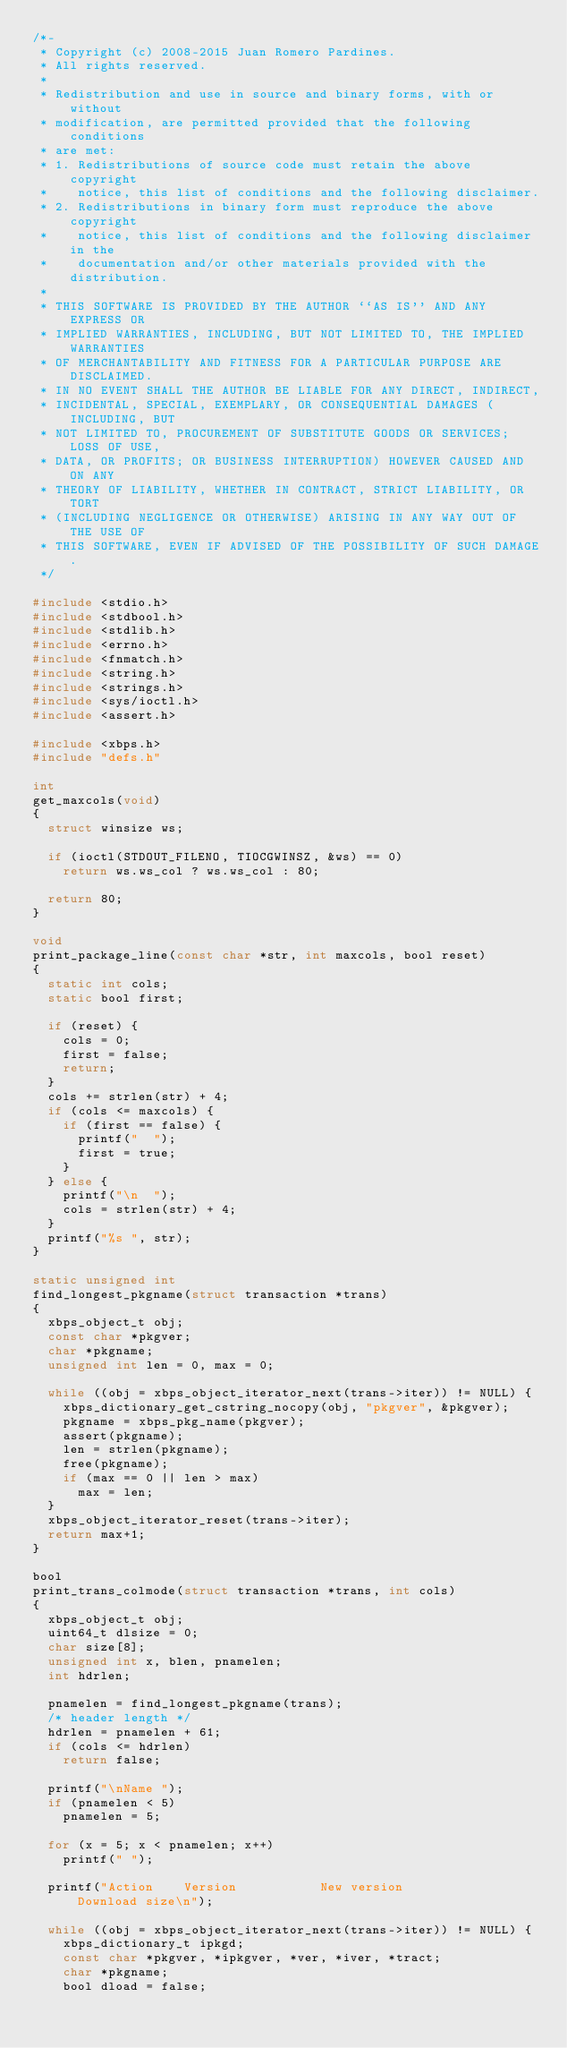Convert code to text. <code><loc_0><loc_0><loc_500><loc_500><_C_>/*-
 * Copyright (c) 2008-2015 Juan Romero Pardines.
 * All rights reserved.
 *
 * Redistribution and use in source and binary forms, with or without
 * modification, are permitted provided that the following conditions
 * are met:
 * 1. Redistributions of source code must retain the above copyright
 *    notice, this list of conditions and the following disclaimer.
 * 2. Redistributions in binary form must reproduce the above copyright
 *    notice, this list of conditions and the following disclaimer in the
 *    documentation and/or other materials provided with the distribution.
 *
 * THIS SOFTWARE IS PROVIDED BY THE AUTHOR ``AS IS'' AND ANY EXPRESS OR
 * IMPLIED WARRANTIES, INCLUDING, BUT NOT LIMITED TO, THE IMPLIED WARRANTIES
 * OF MERCHANTABILITY AND FITNESS FOR A PARTICULAR PURPOSE ARE DISCLAIMED.
 * IN NO EVENT SHALL THE AUTHOR BE LIABLE FOR ANY DIRECT, INDIRECT,
 * INCIDENTAL, SPECIAL, EXEMPLARY, OR CONSEQUENTIAL DAMAGES (INCLUDING, BUT
 * NOT LIMITED TO, PROCUREMENT OF SUBSTITUTE GOODS OR SERVICES; LOSS OF USE,
 * DATA, OR PROFITS; OR BUSINESS INTERRUPTION) HOWEVER CAUSED AND ON ANY
 * THEORY OF LIABILITY, WHETHER IN CONTRACT, STRICT LIABILITY, OR TORT
 * (INCLUDING NEGLIGENCE OR OTHERWISE) ARISING IN ANY WAY OUT OF THE USE OF
 * THIS SOFTWARE, EVEN IF ADVISED OF THE POSSIBILITY OF SUCH DAMAGE.
 */

#include <stdio.h>
#include <stdbool.h>
#include <stdlib.h>
#include <errno.h>
#include <fnmatch.h>
#include <string.h>
#include <strings.h>
#include <sys/ioctl.h>
#include <assert.h>

#include <xbps.h>
#include "defs.h"

int
get_maxcols(void)
{
	struct winsize ws;

	if (ioctl(STDOUT_FILENO, TIOCGWINSZ, &ws) == 0)
		return ws.ws_col ? ws.ws_col : 80;

	return 80;
}

void
print_package_line(const char *str, int maxcols, bool reset)
{
	static int cols;
	static bool first;

	if (reset) {
		cols = 0;
		first = false;
		return;
	}
	cols += strlen(str) + 4;
	if (cols <= maxcols) {
		if (first == false) {
			printf("  ");
			first = true;
		}
	} else {
		printf("\n  ");
		cols = strlen(str) + 4;
	}
	printf("%s ", str);
}

static unsigned int
find_longest_pkgname(struct transaction *trans)
{
	xbps_object_t obj;
	const char *pkgver;
	char *pkgname;
	unsigned int len = 0, max = 0;

	while ((obj = xbps_object_iterator_next(trans->iter)) != NULL) {
		xbps_dictionary_get_cstring_nocopy(obj, "pkgver", &pkgver);
		pkgname = xbps_pkg_name(pkgver);
		assert(pkgname);
		len = strlen(pkgname);
		free(pkgname);
		if (max == 0 || len > max)
			max = len;
	}
	xbps_object_iterator_reset(trans->iter);
	return max+1;
}

bool
print_trans_colmode(struct transaction *trans, int cols)
{
	xbps_object_t obj;
	uint64_t dlsize = 0;
	char size[8];
	unsigned int x, blen, pnamelen;
	int hdrlen;

	pnamelen = find_longest_pkgname(trans);
	/* header length */
	hdrlen = pnamelen + 61;
	if (cols <= hdrlen)
		return false;

	printf("\nName ");
	if (pnamelen < 5)
		pnamelen = 5;

	for (x = 5; x < pnamelen; x++)
		printf(" ");

	printf("Action    Version           New version            Download size\n");

	while ((obj = xbps_object_iterator_next(trans->iter)) != NULL) {
		xbps_dictionary_t ipkgd;
		const char *pkgver, *ipkgver, *ver, *iver, *tract;
		char *pkgname;
		bool dload = false;
</code> 